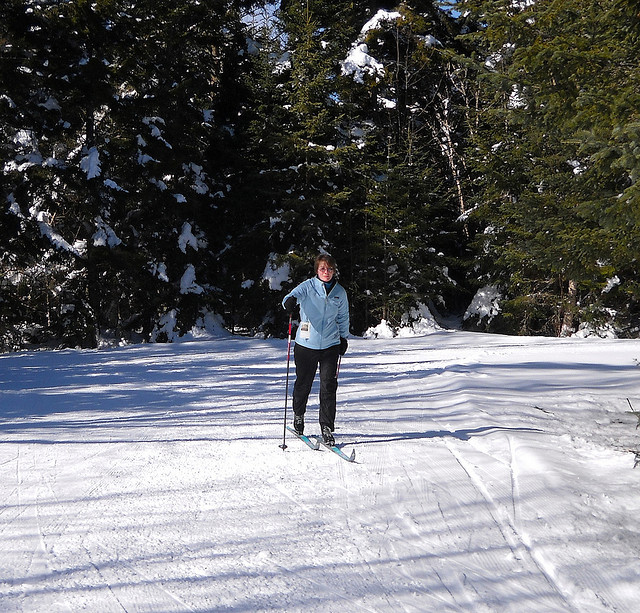How many dogs are standing in boat? The question seems to be based on a misunderstanding as there is no boat or dogs in the image. It actually depicts a person cross-country skiing in a snowy forest, suggesting it's a winter activity scene without any canines or boat present. 